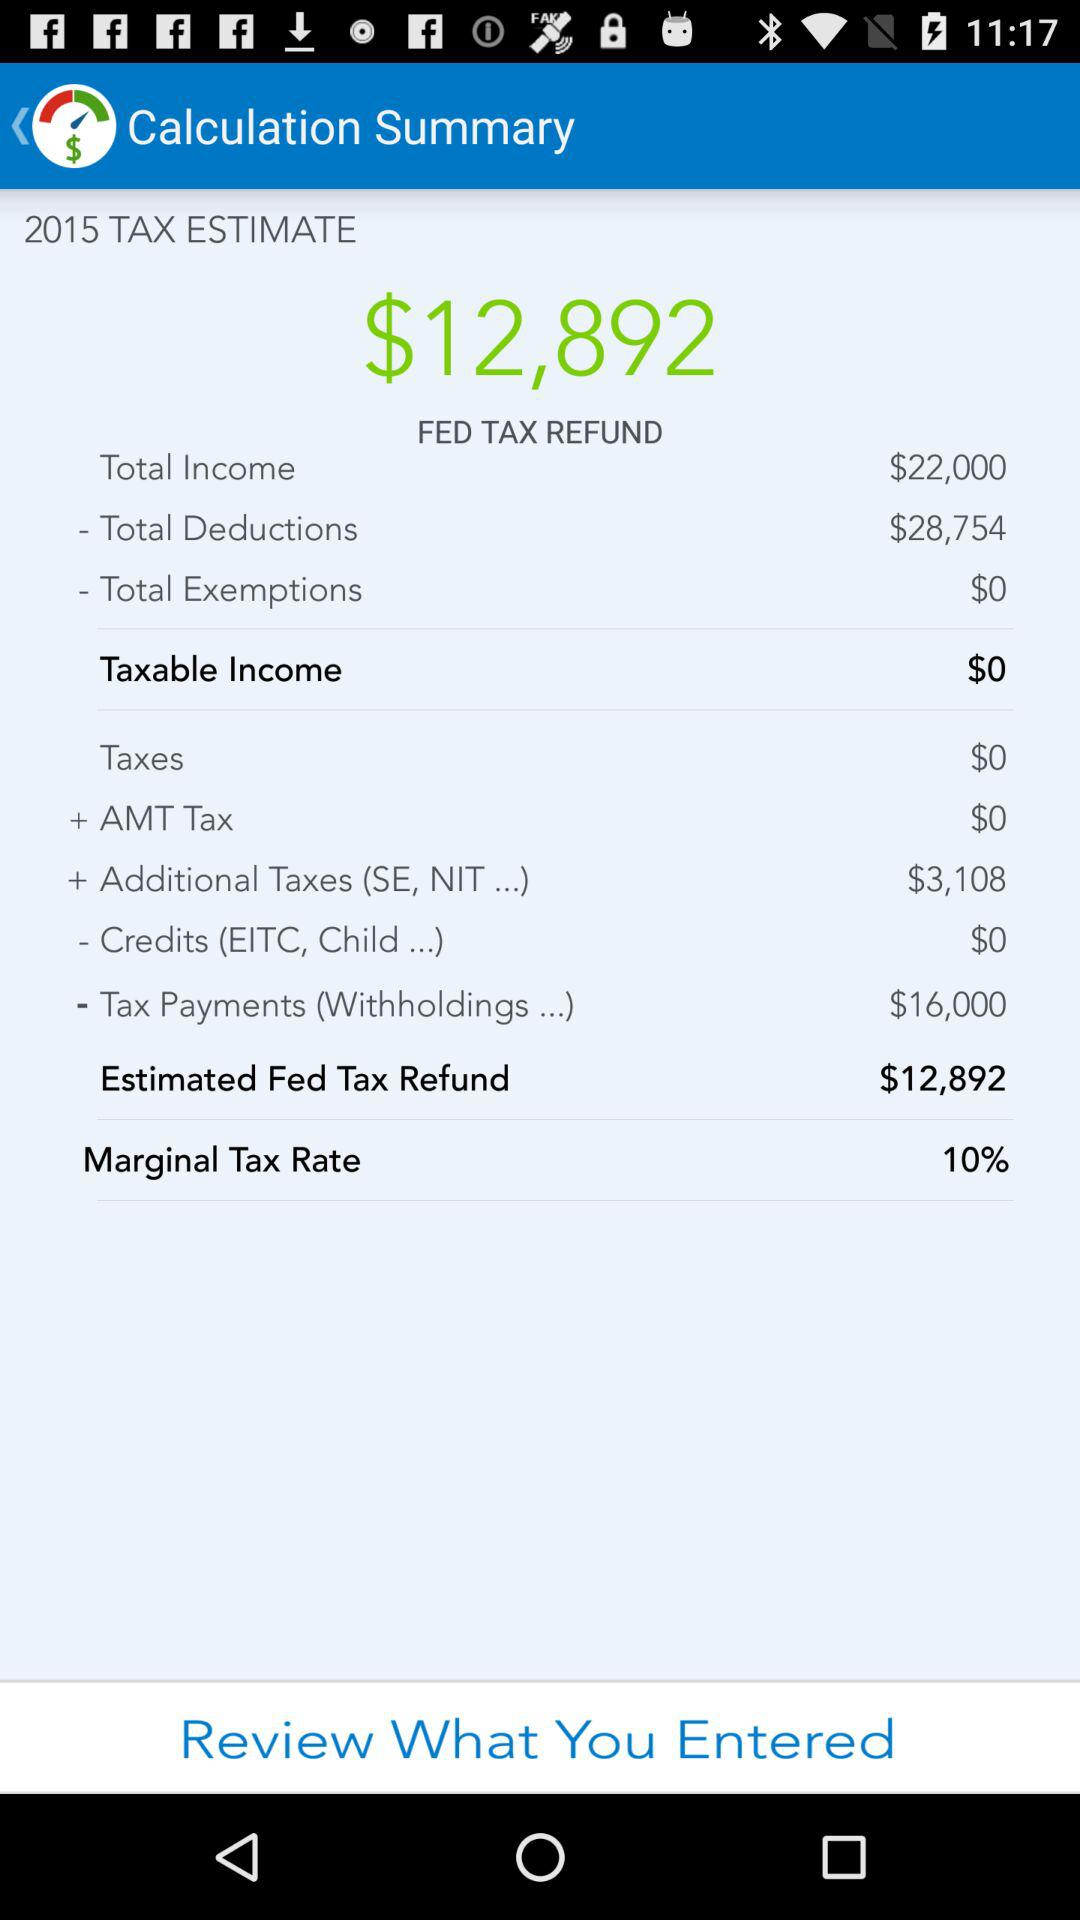What is the total fed tax refund? The total fed tax amount is $12,892. 